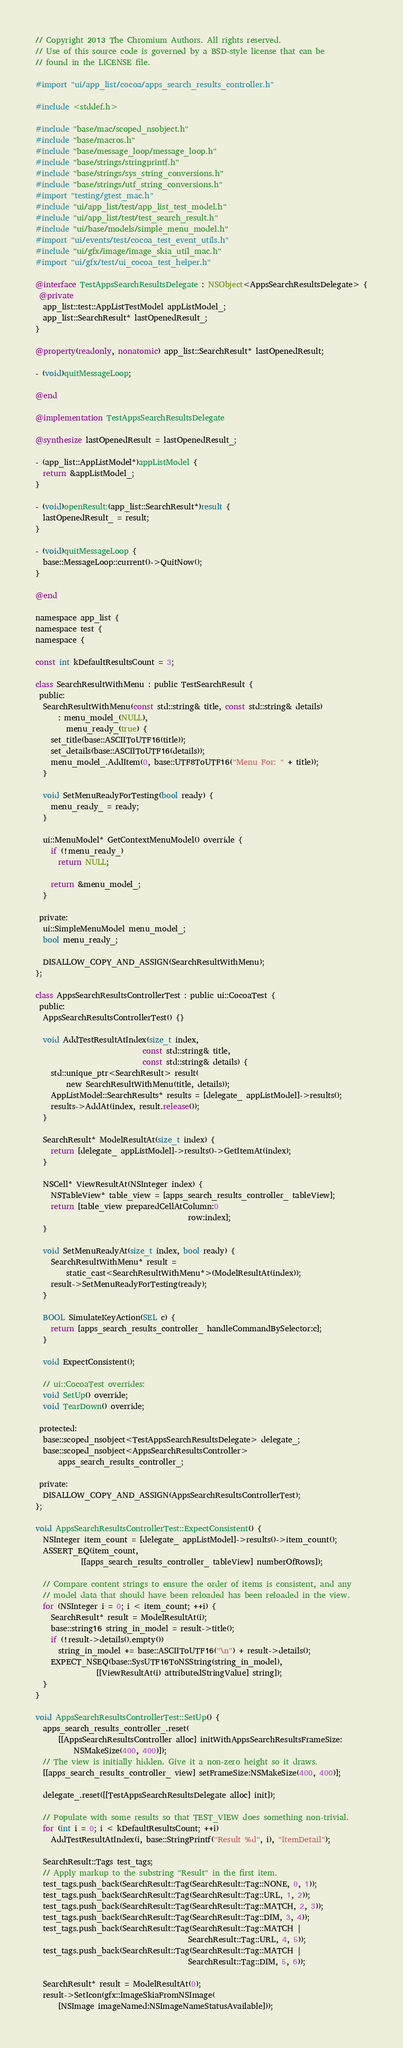Convert code to text. <code><loc_0><loc_0><loc_500><loc_500><_ObjectiveC_>// Copyright 2013 The Chromium Authors. All rights reserved.
// Use of this source code is governed by a BSD-style license that can be
// found in the LICENSE file.

#import "ui/app_list/cocoa/apps_search_results_controller.h"

#include <stddef.h>

#include "base/mac/scoped_nsobject.h"
#include "base/macros.h"
#include "base/message_loop/message_loop.h"
#include "base/strings/stringprintf.h"
#include "base/strings/sys_string_conversions.h"
#include "base/strings/utf_string_conversions.h"
#import "testing/gtest_mac.h"
#include "ui/app_list/test/app_list_test_model.h"
#include "ui/app_list/test/test_search_result.h"
#include "ui/base/models/simple_menu_model.h"
#import "ui/events/test/cocoa_test_event_utils.h"
#include "ui/gfx/image/image_skia_util_mac.h"
#import "ui/gfx/test/ui_cocoa_test_helper.h"

@interface TestAppsSearchResultsDelegate : NSObject<AppsSearchResultsDelegate> {
 @private
  app_list::test::AppListTestModel appListModel_;
  app_list::SearchResult* lastOpenedResult_;
}

@property(readonly, nonatomic) app_list::SearchResult* lastOpenedResult;

- (void)quitMessageLoop;

@end

@implementation TestAppsSearchResultsDelegate

@synthesize lastOpenedResult = lastOpenedResult_;

- (app_list::AppListModel*)appListModel {
  return &appListModel_;
}

- (void)openResult:(app_list::SearchResult*)result {
  lastOpenedResult_ = result;
}

- (void)quitMessageLoop {
  base::MessageLoop::current()->QuitNow();
}

@end

namespace app_list {
namespace test {
namespace {

const int kDefaultResultsCount = 3;

class SearchResultWithMenu : public TestSearchResult {
 public:
  SearchResultWithMenu(const std::string& title, const std::string& details)
      : menu_model_(NULL),
        menu_ready_(true) {
    set_title(base::ASCIIToUTF16(title));
    set_details(base::ASCIIToUTF16(details));
    menu_model_.AddItem(0, base::UTF8ToUTF16("Menu For: " + title));
  }

  void SetMenuReadyForTesting(bool ready) {
    menu_ready_ = ready;
  }

  ui::MenuModel* GetContextMenuModel() override {
    if (!menu_ready_)
      return NULL;

    return &menu_model_;
  }

 private:
  ui::SimpleMenuModel menu_model_;
  bool menu_ready_;

  DISALLOW_COPY_AND_ASSIGN(SearchResultWithMenu);
};

class AppsSearchResultsControllerTest : public ui::CocoaTest {
 public:
  AppsSearchResultsControllerTest() {}

  void AddTestResultAtIndex(size_t index,
                            const std::string& title,
                            const std::string& details) {
    std::unique_ptr<SearchResult> result(
        new SearchResultWithMenu(title, details));
    AppListModel::SearchResults* results = [delegate_ appListModel]->results();
    results->AddAt(index, result.release());
  }

  SearchResult* ModelResultAt(size_t index) {
    return [delegate_ appListModel]->results()->GetItemAt(index);
  }

  NSCell* ViewResultAt(NSInteger index) {
    NSTableView* table_view = [apps_search_results_controller_ tableView];
    return [table_view preparedCellAtColumn:0
                                        row:index];
  }

  void SetMenuReadyAt(size_t index, bool ready) {
    SearchResultWithMenu* result =
        static_cast<SearchResultWithMenu*>(ModelResultAt(index));
    result->SetMenuReadyForTesting(ready);
  }

  BOOL SimulateKeyAction(SEL c) {
    return [apps_search_results_controller_ handleCommandBySelector:c];
  }

  void ExpectConsistent();

  // ui::CocoaTest overrides:
  void SetUp() override;
  void TearDown() override;

 protected:
  base::scoped_nsobject<TestAppsSearchResultsDelegate> delegate_;
  base::scoped_nsobject<AppsSearchResultsController>
      apps_search_results_controller_;

 private:
  DISALLOW_COPY_AND_ASSIGN(AppsSearchResultsControllerTest);
};

void AppsSearchResultsControllerTest::ExpectConsistent() {
  NSInteger item_count = [delegate_ appListModel]->results()->item_count();
  ASSERT_EQ(item_count,
            [[apps_search_results_controller_ tableView] numberOfRows]);

  // Compare content strings to ensure the order of items is consistent, and any
  // model data that should have been reloaded has been reloaded in the view.
  for (NSInteger i = 0; i < item_count; ++i) {
    SearchResult* result = ModelResultAt(i);
    base::string16 string_in_model = result->title();
    if (!result->details().empty())
      string_in_model += base::ASCIIToUTF16("\n") + result->details();
    EXPECT_NSEQ(base::SysUTF16ToNSString(string_in_model),
                [[ViewResultAt(i) attributedStringValue] string]);
  }
}

void AppsSearchResultsControllerTest::SetUp() {
  apps_search_results_controller_.reset(
      [[AppsSearchResultsController alloc] initWithAppsSearchResultsFrameSize:
          NSMakeSize(400, 400)]);
  // The view is initially hidden. Give it a non-zero height so it draws.
  [[apps_search_results_controller_ view] setFrameSize:NSMakeSize(400, 400)];

  delegate_.reset([[TestAppsSearchResultsDelegate alloc] init]);

  // Populate with some results so that TEST_VIEW does something non-trivial.
  for (int i = 0; i < kDefaultResultsCount; ++i)
    AddTestResultAtIndex(i, base::StringPrintf("Result %d", i), "ItemDetail");

  SearchResult::Tags test_tags;
  // Apply markup to the substring "Result" in the first item.
  test_tags.push_back(SearchResult::Tag(SearchResult::Tag::NONE, 0, 1));
  test_tags.push_back(SearchResult::Tag(SearchResult::Tag::URL, 1, 2));
  test_tags.push_back(SearchResult::Tag(SearchResult::Tag::MATCH, 2, 3));
  test_tags.push_back(SearchResult::Tag(SearchResult::Tag::DIM, 3, 4));
  test_tags.push_back(SearchResult::Tag(SearchResult::Tag::MATCH |
                                        SearchResult::Tag::URL, 4, 5));
  test_tags.push_back(SearchResult::Tag(SearchResult::Tag::MATCH |
                                        SearchResult::Tag::DIM, 5, 6));

  SearchResult* result = ModelResultAt(0);
  result->SetIcon(gfx::ImageSkiaFromNSImage(
      [NSImage imageNamed:NSImageNameStatusAvailable]));</code> 